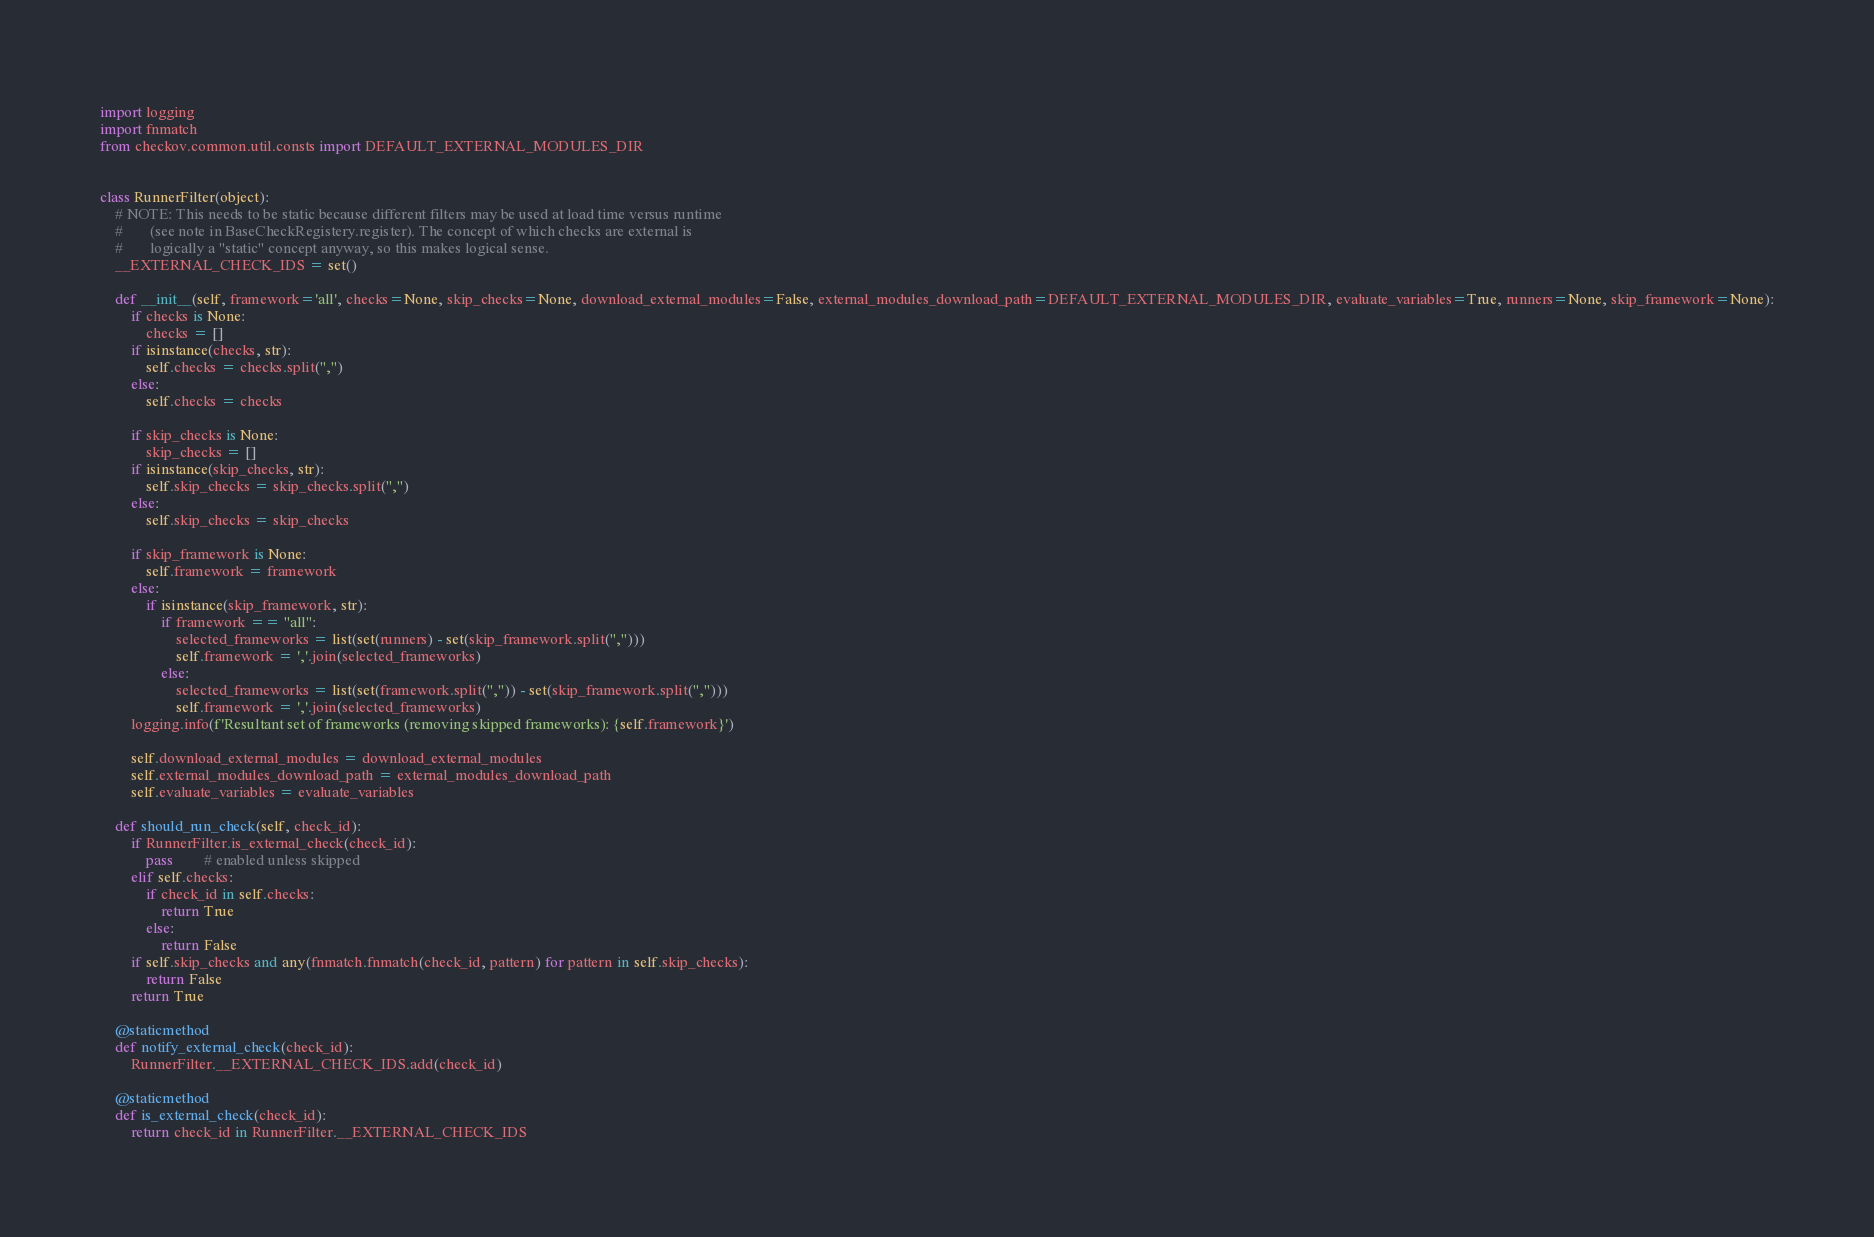Convert code to text. <code><loc_0><loc_0><loc_500><loc_500><_Python_>import logging
import fnmatch
from checkov.common.util.consts import DEFAULT_EXTERNAL_MODULES_DIR


class RunnerFilter(object):
    # NOTE: This needs to be static because different filters may be used at load time versus runtime
    #       (see note in BaseCheckRegistery.register). The concept of which checks are external is
    #       logically a "static" concept anyway, so this makes logical sense.
    __EXTERNAL_CHECK_IDS = set()

    def __init__(self, framework='all', checks=None, skip_checks=None, download_external_modules=False, external_modules_download_path=DEFAULT_EXTERNAL_MODULES_DIR, evaluate_variables=True, runners=None, skip_framework=None):
        if checks is None:
            checks = []
        if isinstance(checks, str):
            self.checks = checks.split(",")
        else:
            self.checks = checks

        if skip_checks is None:
            skip_checks = []
        if isinstance(skip_checks, str):
            self.skip_checks = skip_checks.split(",")
        else:
            self.skip_checks = skip_checks

        if skip_framework is None:
            self.framework = framework
        else:
            if isinstance(skip_framework, str):
                if framework == "all":
                    selected_frameworks = list(set(runners) - set(skip_framework.split(",")))
                    self.framework = ','.join(selected_frameworks)
                else:
                    selected_frameworks = list(set(framework.split(",")) - set(skip_framework.split(",")))
                    self.framework = ','.join(selected_frameworks)
        logging.info(f'Resultant set of frameworks (removing skipped frameworks): {self.framework}')

        self.download_external_modules = download_external_modules
        self.external_modules_download_path = external_modules_download_path
        self.evaluate_variables = evaluate_variables

    def should_run_check(self, check_id):
        if RunnerFilter.is_external_check(check_id):
            pass        # enabled unless skipped
        elif self.checks:
            if check_id in self.checks:
                return True
            else:
                return False
        if self.skip_checks and any(fnmatch.fnmatch(check_id, pattern) for pattern in self.skip_checks):
            return False
        return True

    @staticmethod
    def notify_external_check(check_id):
        RunnerFilter.__EXTERNAL_CHECK_IDS.add(check_id)

    @staticmethod
    def is_external_check(check_id):
        return check_id in RunnerFilter.__EXTERNAL_CHECK_IDS
</code> 